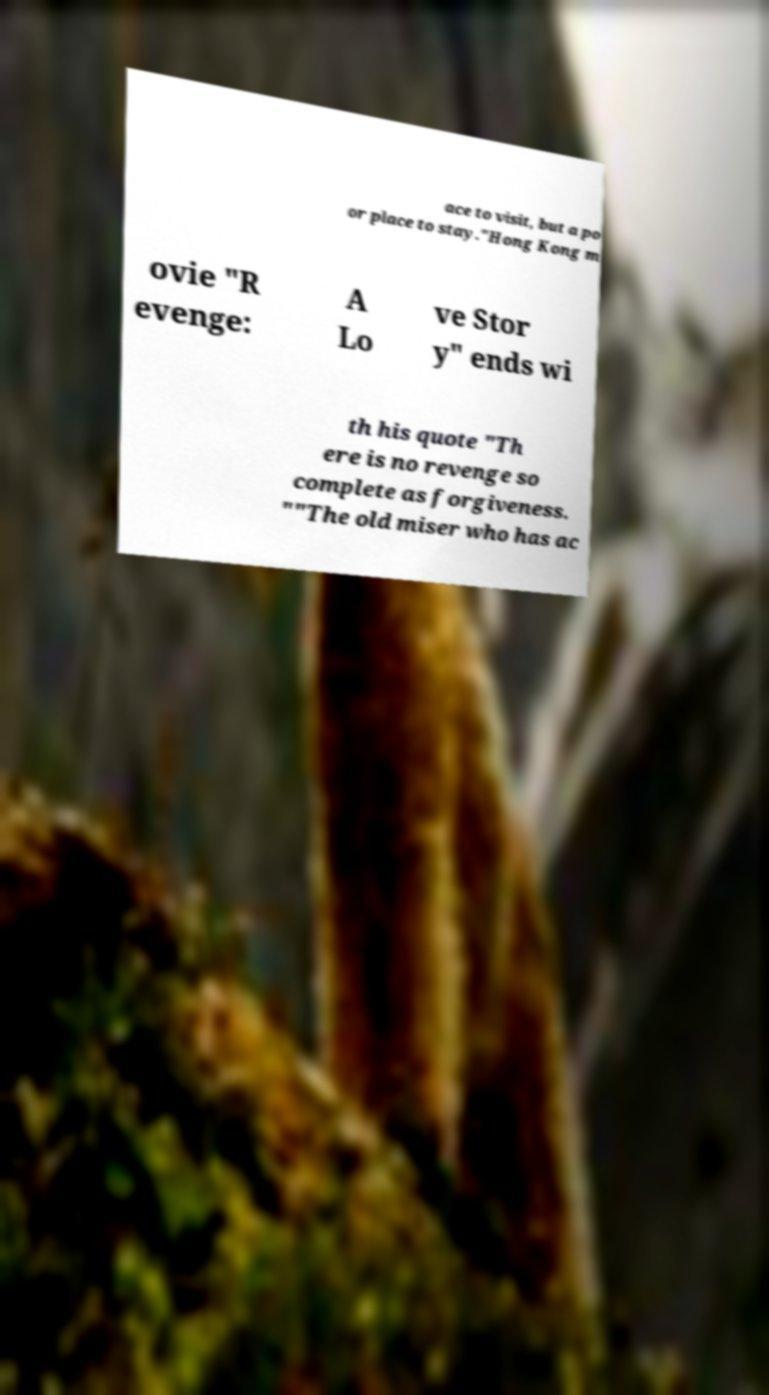Please identify and transcribe the text found in this image. ace to visit, but a po or place to stay."Hong Kong m ovie "R evenge: A Lo ve Stor y" ends wi th his quote "Th ere is no revenge so complete as forgiveness. ""The old miser who has ac 